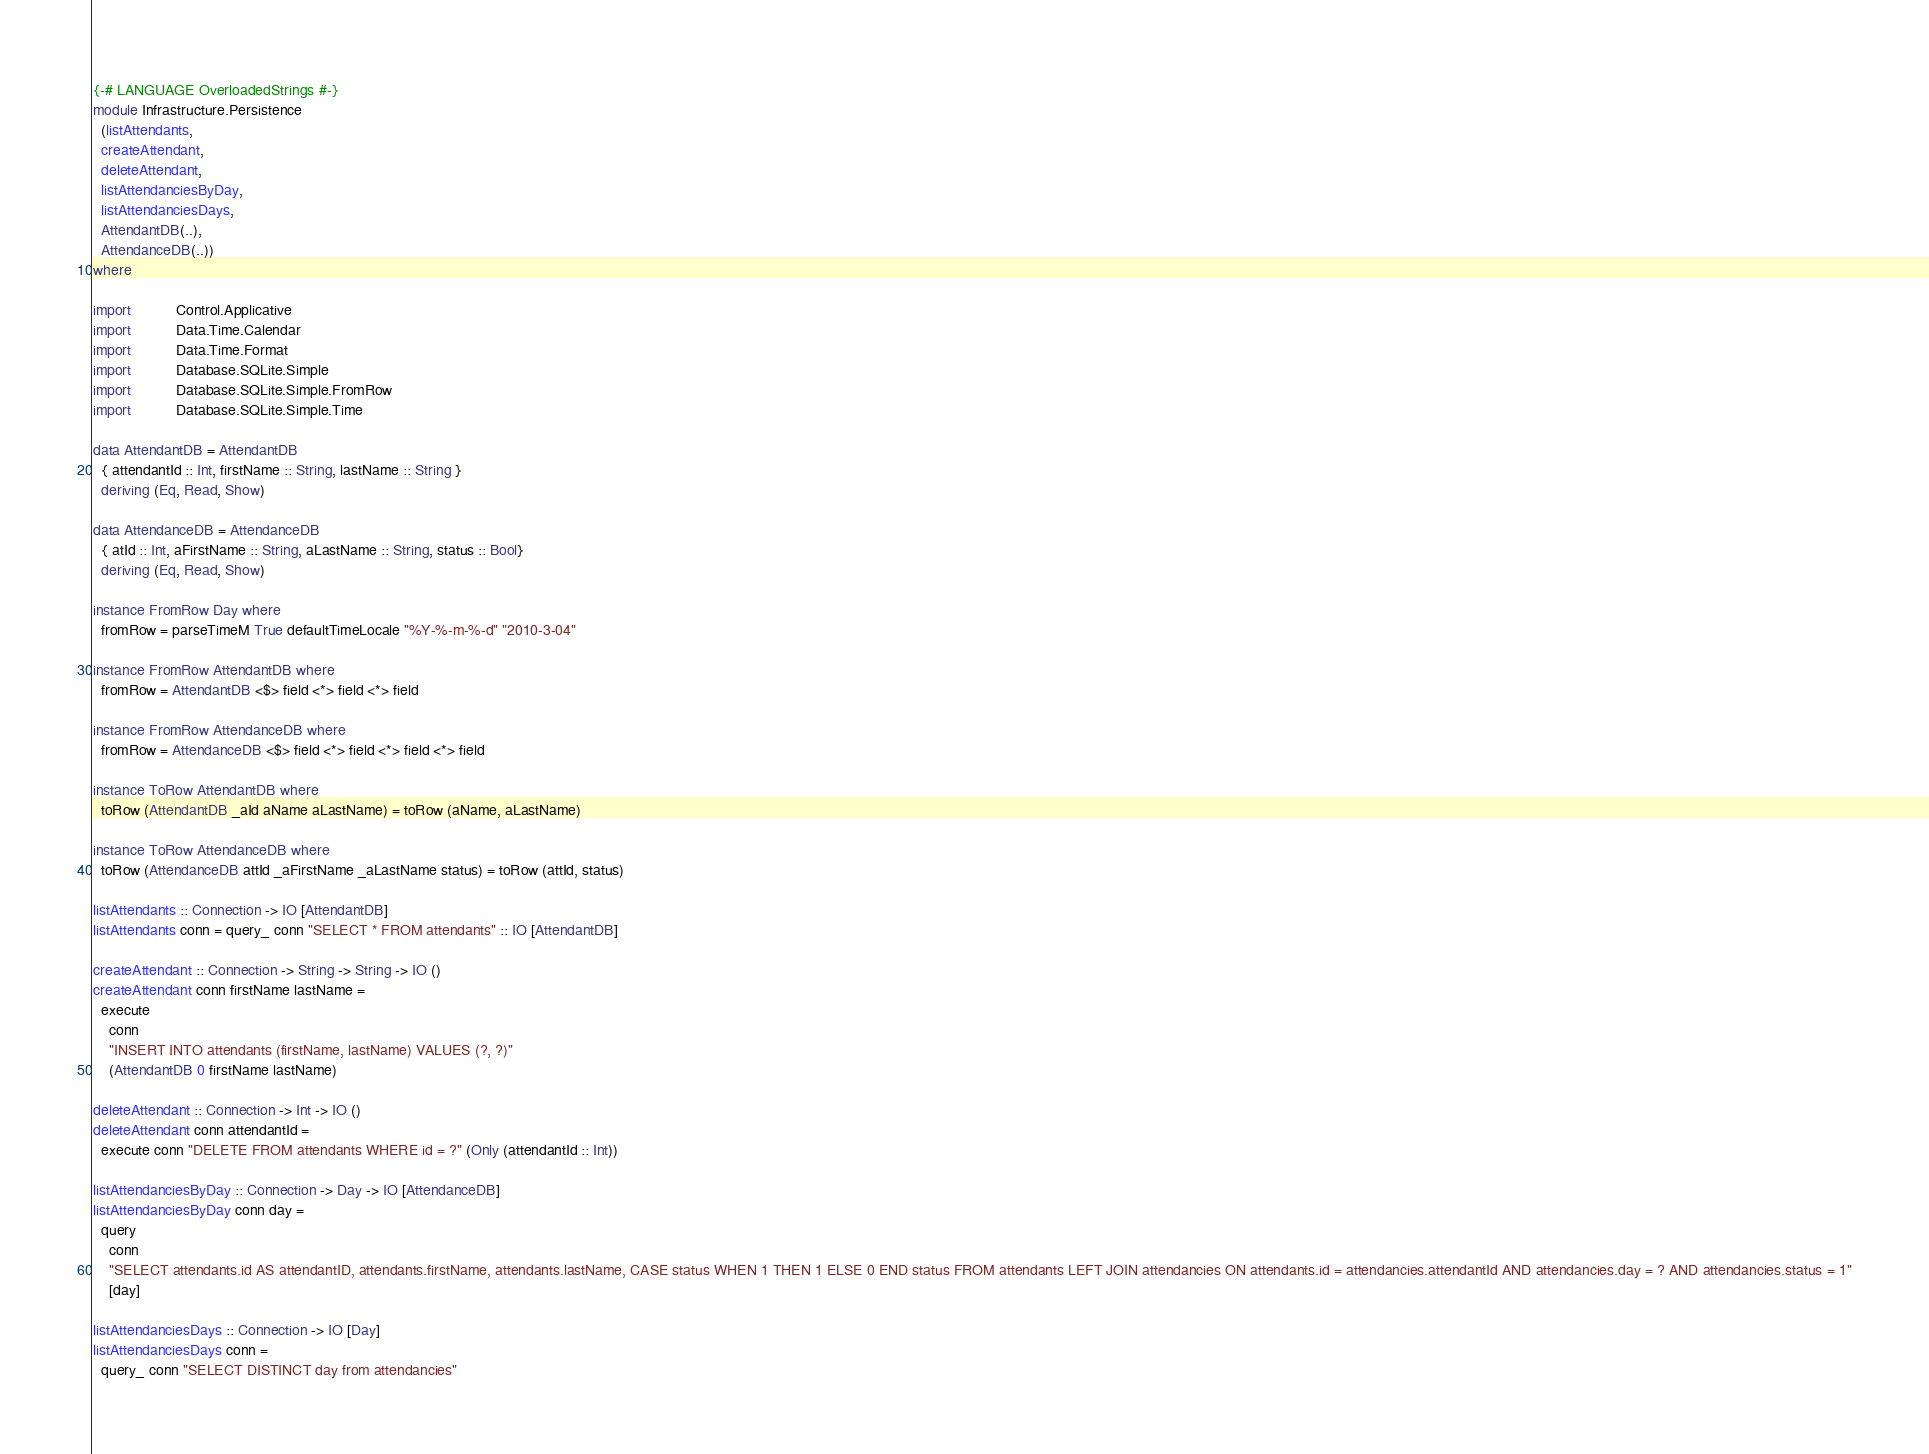<code> <loc_0><loc_0><loc_500><loc_500><_Haskell_>{-# LANGUAGE OverloadedStrings #-}
module Infrastructure.Persistence
  (listAttendants,
  createAttendant,
  deleteAttendant,
  listAttendanciesByDay,
  listAttendanciesDays,
  AttendantDB(..),
  AttendanceDB(..))
where

import           Control.Applicative
import           Data.Time.Calendar
import           Data.Time.Format
import           Database.SQLite.Simple
import           Database.SQLite.Simple.FromRow
import           Database.SQLite.Simple.Time

data AttendantDB = AttendantDB
  { attendantId :: Int, firstName :: String, lastName :: String }
  deriving (Eq, Read, Show)

data AttendanceDB = AttendanceDB
  { atId :: Int, aFirstName :: String, aLastName :: String, status :: Bool}
  deriving (Eq, Read, Show)

instance FromRow Day where
  fromRow = parseTimeM True defaultTimeLocale "%Y-%-m-%-d" "2010-3-04"

instance FromRow AttendantDB where
  fromRow = AttendantDB <$> field <*> field <*> field

instance FromRow AttendanceDB where
  fromRow = AttendanceDB <$> field <*> field <*> field <*> field

instance ToRow AttendantDB where
  toRow (AttendantDB _aId aName aLastName) = toRow (aName, aLastName)

instance ToRow AttendanceDB where
  toRow (AttendanceDB attId _aFirstName _aLastName status) = toRow (attId, status)

listAttendants :: Connection -> IO [AttendantDB]
listAttendants conn = query_ conn "SELECT * FROM attendants" :: IO [AttendantDB]

createAttendant :: Connection -> String -> String -> IO ()
createAttendant conn firstName lastName =
  execute
    conn
    "INSERT INTO attendants (firstName, lastName) VALUES (?, ?)"
    (AttendantDB 0 firstName lastName)

deleteAttendant :: Connection -> Int -> IO ()
deleteAttendant conn attendantId =
  execute conn "DELETE FROM attendants WHERE id = ?" (Only (attendantId :: Int))

listAttendanciesByDay :: Connection -> Day -> IO [AttendanceDB]
listAttendanciesByDay conn day =
  query
    conn
    "SELECT attendants.id AS attendantID, attendants.firstName, attendants.lastName, CASE status WHEN 1 THEN 1 ELSE 0 END status FROM attendants LEFT JOIN attendancies ON attendants.id = attendancies.attendantId AND attendancies.day = ? AND attendancies.status = 1"
    [day]

listAttendanciesDays :: Connection -> IO [Day]
listAttendanciesDays conn =
  query_ conn "SELECT DISTINCT day from attendancies"
</code> 